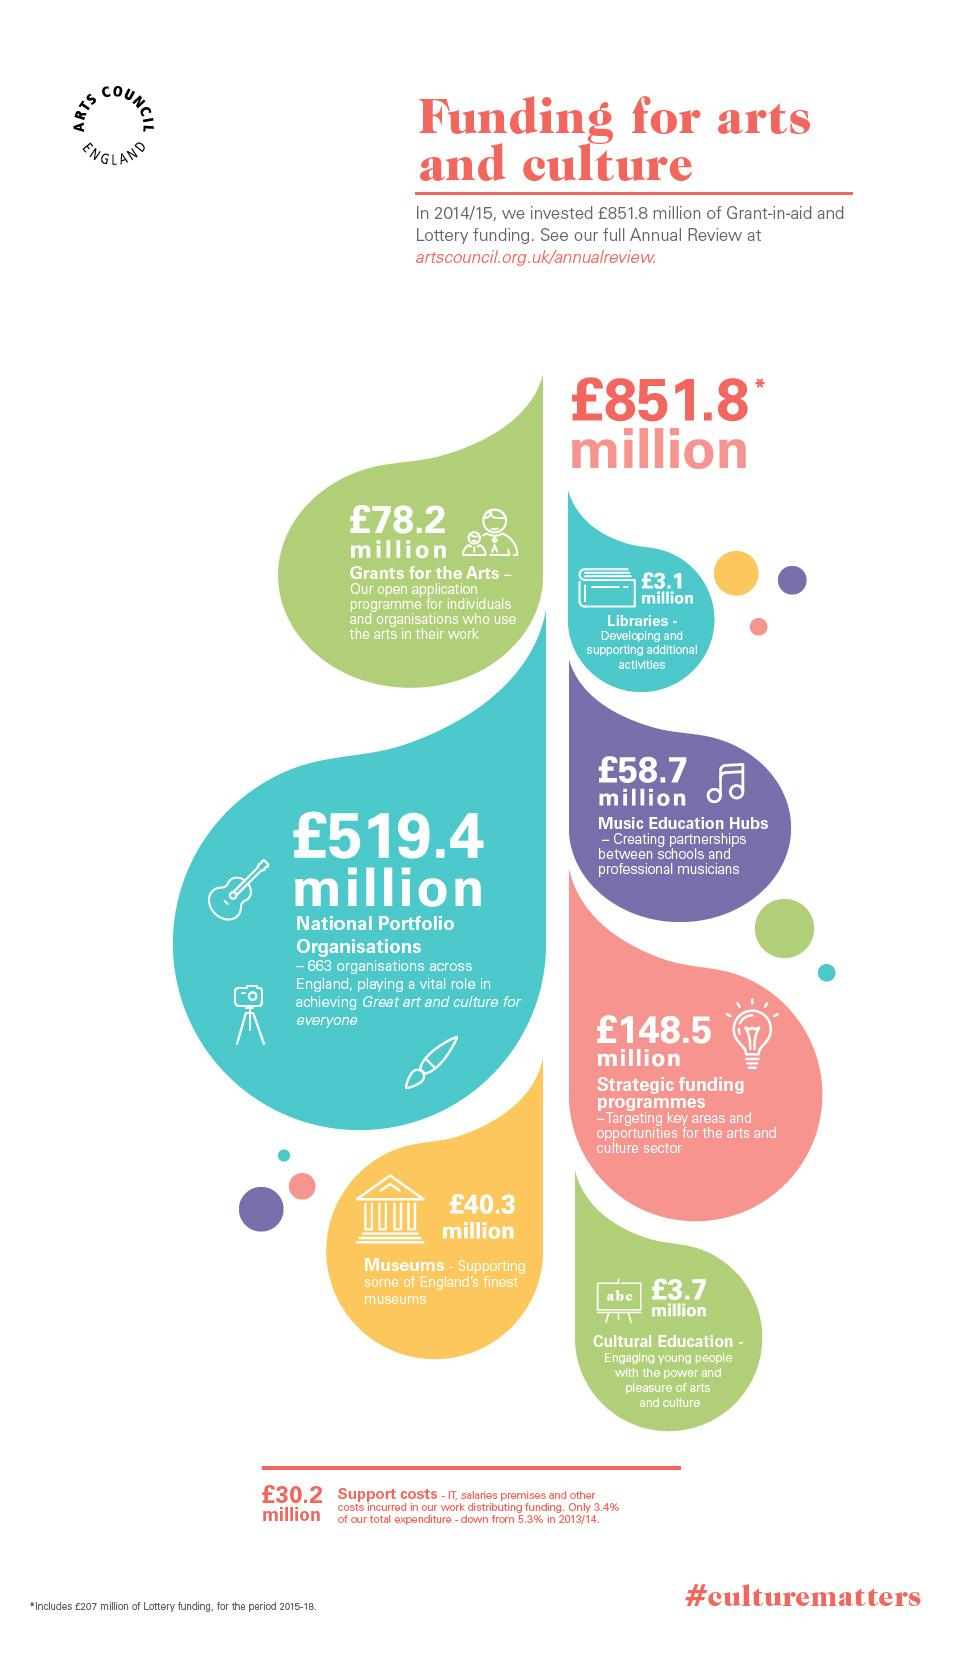Point out several critical features in this image. National Portfolio Organizations have received the largest amount of grants, with the greatest recipient being [insert name]. The hashtag provided is #culturematters. 